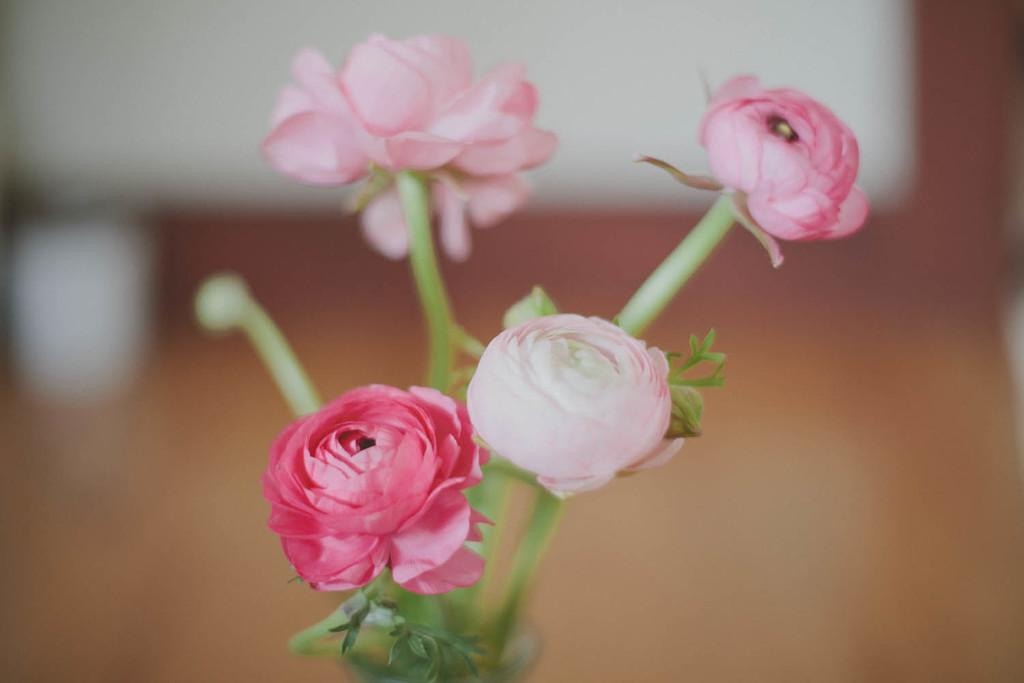What type of plant elements can be seen in the image? There are flowers, leaves, and stems in the image. Can you describe the background of the image? The background of the image is blurred. What type of cracker is being used to express regret in the image? There is no cracker or expression of regret present in the image; it features flowers, leaves, and stems with a blurred background. 